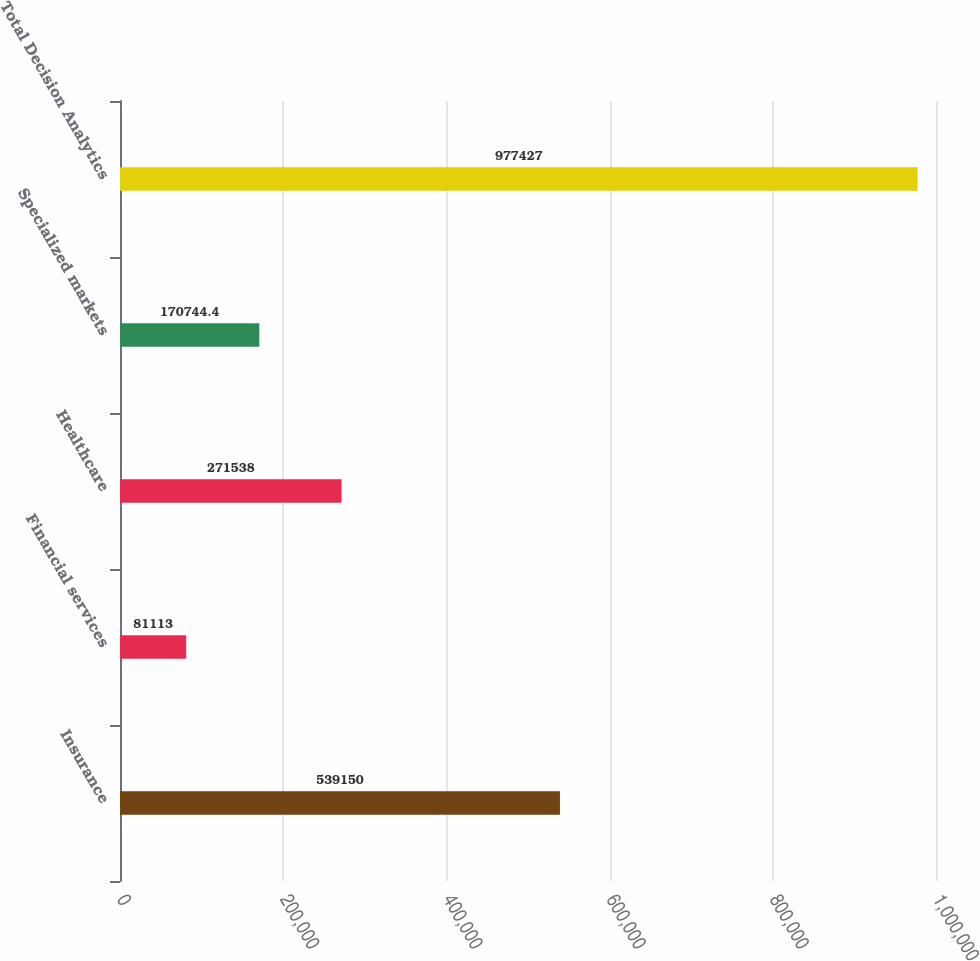<chart> <loc_0><loc_0><loc_500><loc_500><bar_chart><fcel>Insurance<fcel>Financial services<fcel>Healthcare<fcel>Specialized markets<fcel>Total Decision Analytics<nl><fcel>539150<fcel>81113<fcel>271538<fcel>170744<fcel>977427<nl></chart> 